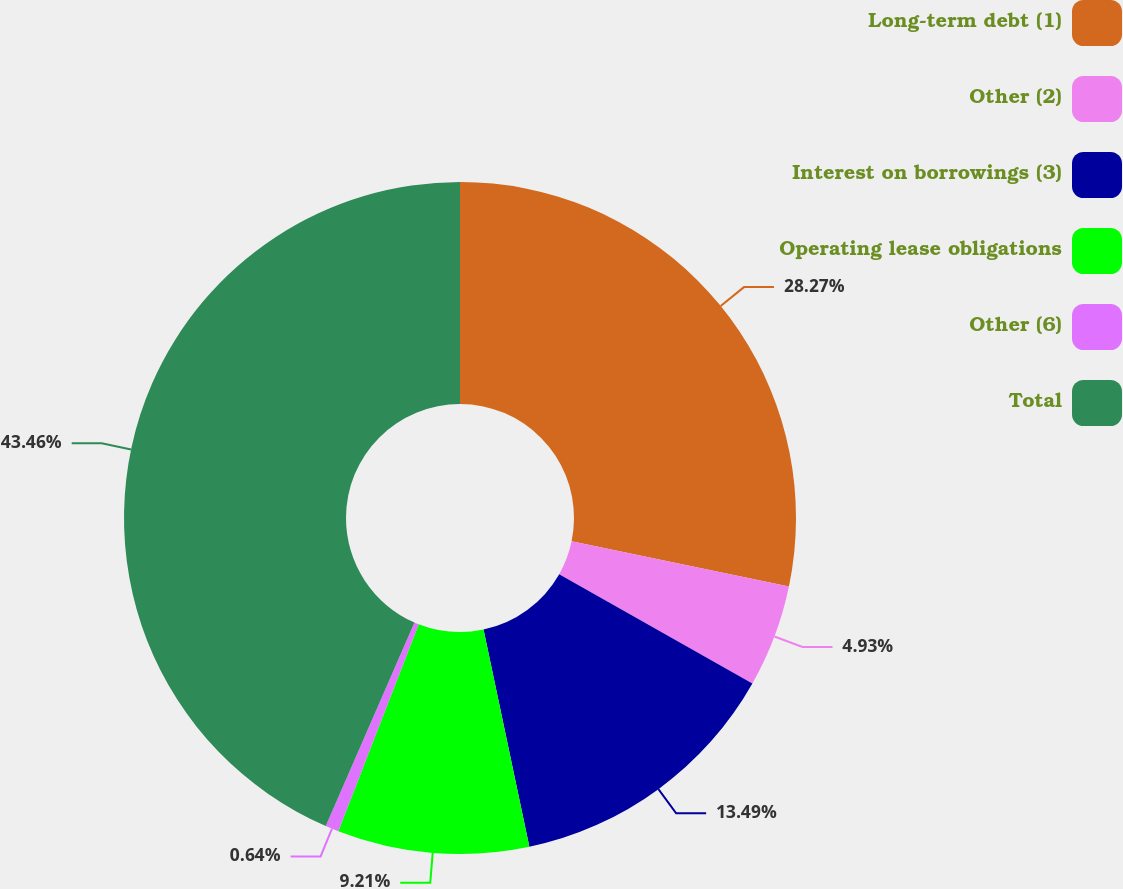Convert chart to OTSL. <chart><loc_0><loc_0><loc_500><loc_500><pie_chart><fcel>Long-term debt (1)<fcel>Other (2)<fcel>Interest on borrowings (3)<fcel>Operating lease obligations<fcel>Other (6)<fcel>Total<nl><fcel>28.27%<fcel>4.93%<fcel>13.49%<fcel>9.21%<fcel>0.64%<fcel>43.46%<nl></chart> 